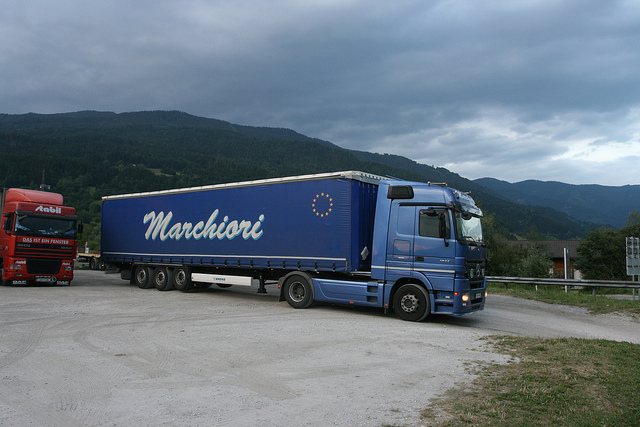Please identify all text content in this image. MARCHIORI Aabil 